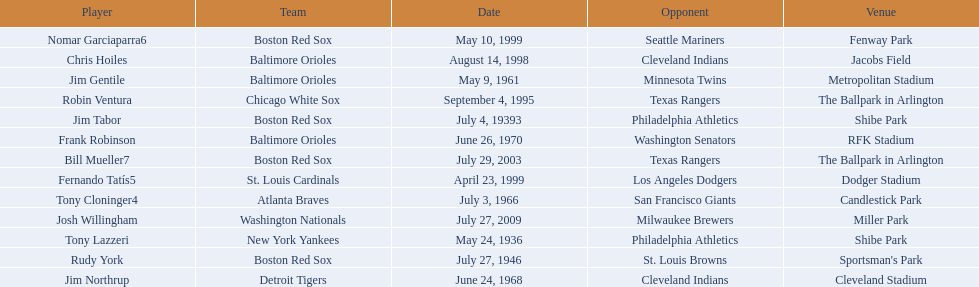Who are all the opponents? Philadelphia Athletics, Philadelphia Athletics, St. Louis Browns, Minnesota Twins, San Francisco Giants, Cleveland Indians, Washington Senators, Texas Rangers, Cleveland Indians, Los Angeles Dodgers, Seattle Mariners, Texas Rangers, Milwaukee Brewers. What teams played on july 27, 1946? Boston Red Sox, July 27, 1946, St. Louis Browns. Who was the opponent in this game? St. Louis Browns. 